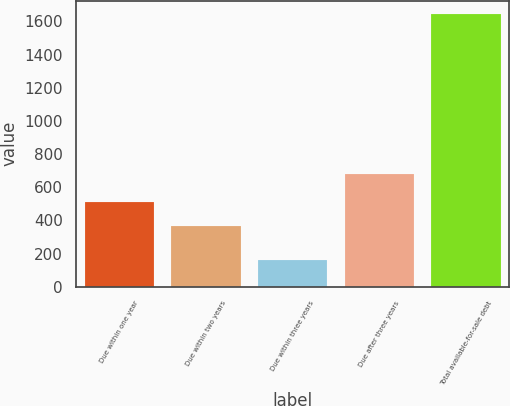<chart> <loc_0><loc_0><loc_500><loc_500><bar_chart><fcel>Due within one year<fcel>Due within two years<fcel>Due within three years<fcel>Due after three years<fcel>Total available-for-sale debt<nl><fcel>512.9<fcel>365<fcel>164<fcel>682<fcel>1643<nl></chart> 